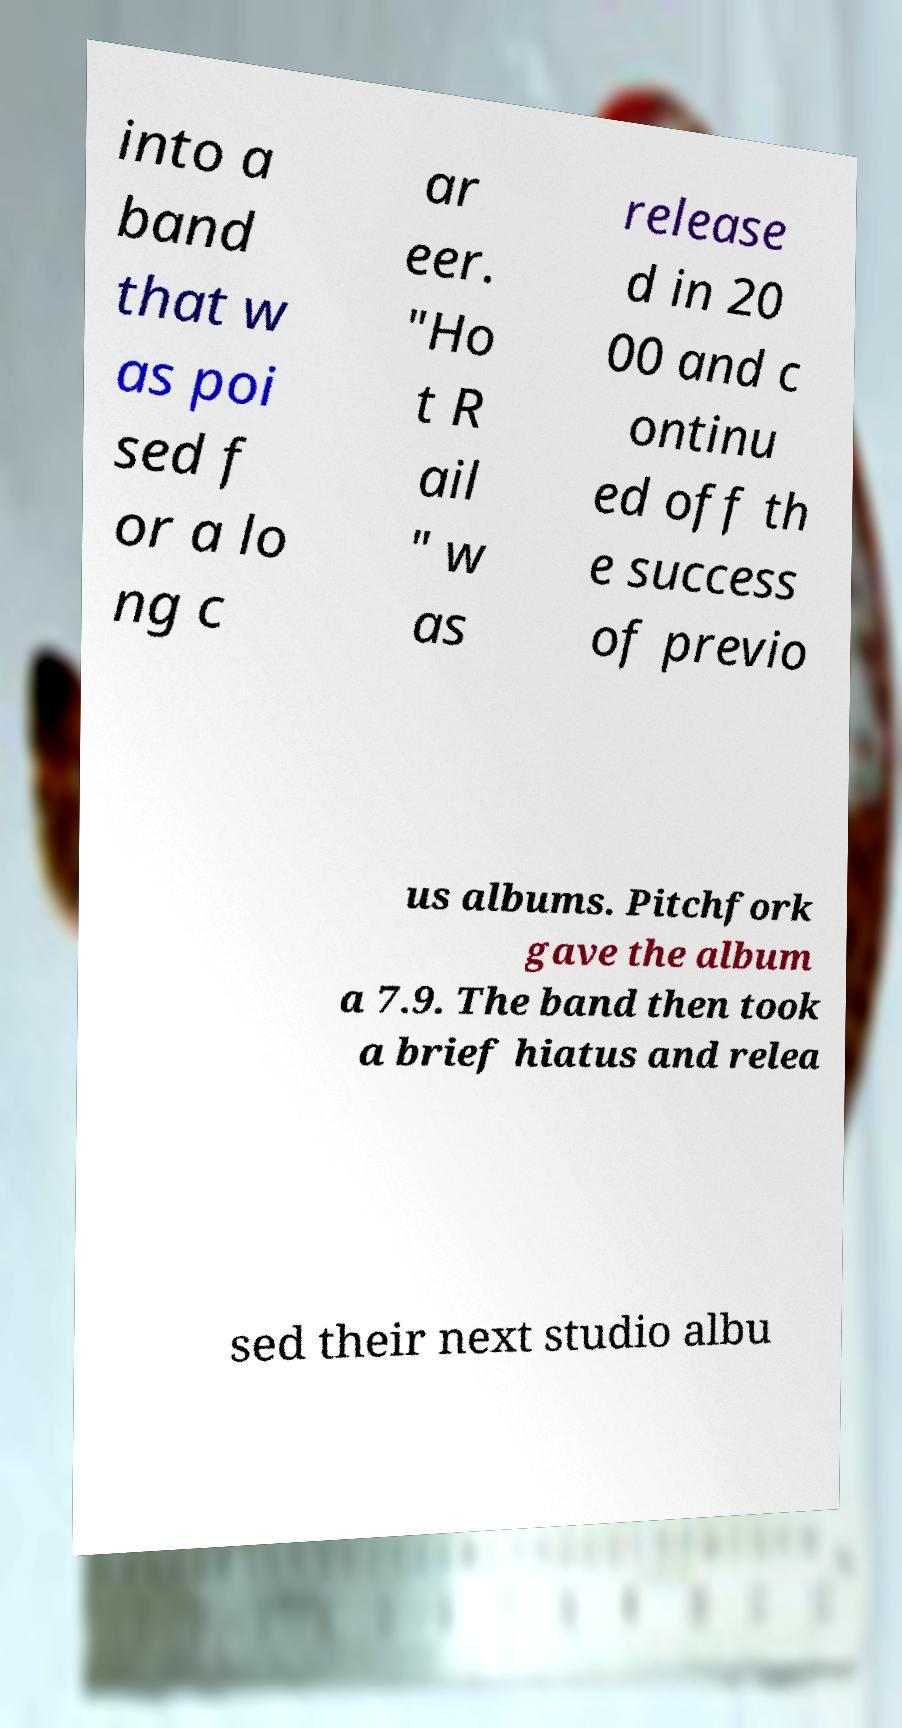Can you read and provide the text displayed in the image?This photo seems to have some interesting text. Can you extract and type it out for me? into a band that w as poi sed f or a lo ng c ar eer. "Ho t R ail " w as release d in 20 00 and c ontinu ed off th e success of previo us albums. Pitchfork gave the album a 7.9. The band then took a brief hiatus and relea sed their next studio albu 